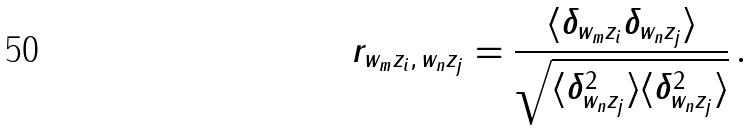Convert formula to latex. <formula><loc_0><loc_0><loc_500><loc_500>r _ { w _ { m } z _ { i } , \, w _ { n } z _ { j } } = \frac { \langle \delta _ { w _ { m } z _ { i } } \delta _ { w _ { n } z _ { j } } \rangle } { \sqrt { \langle \delta _ { w _ { n } z _ { j } } ^ { 2 } \rangle \langle \delta _ { w _ { n } z _ { j } } ^ { 2 } \rangle } } \, .</formula> 